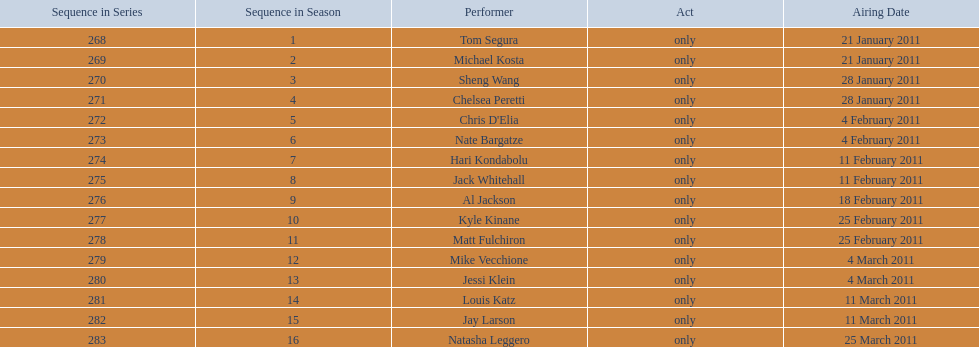Which month had the most air dates? February. 